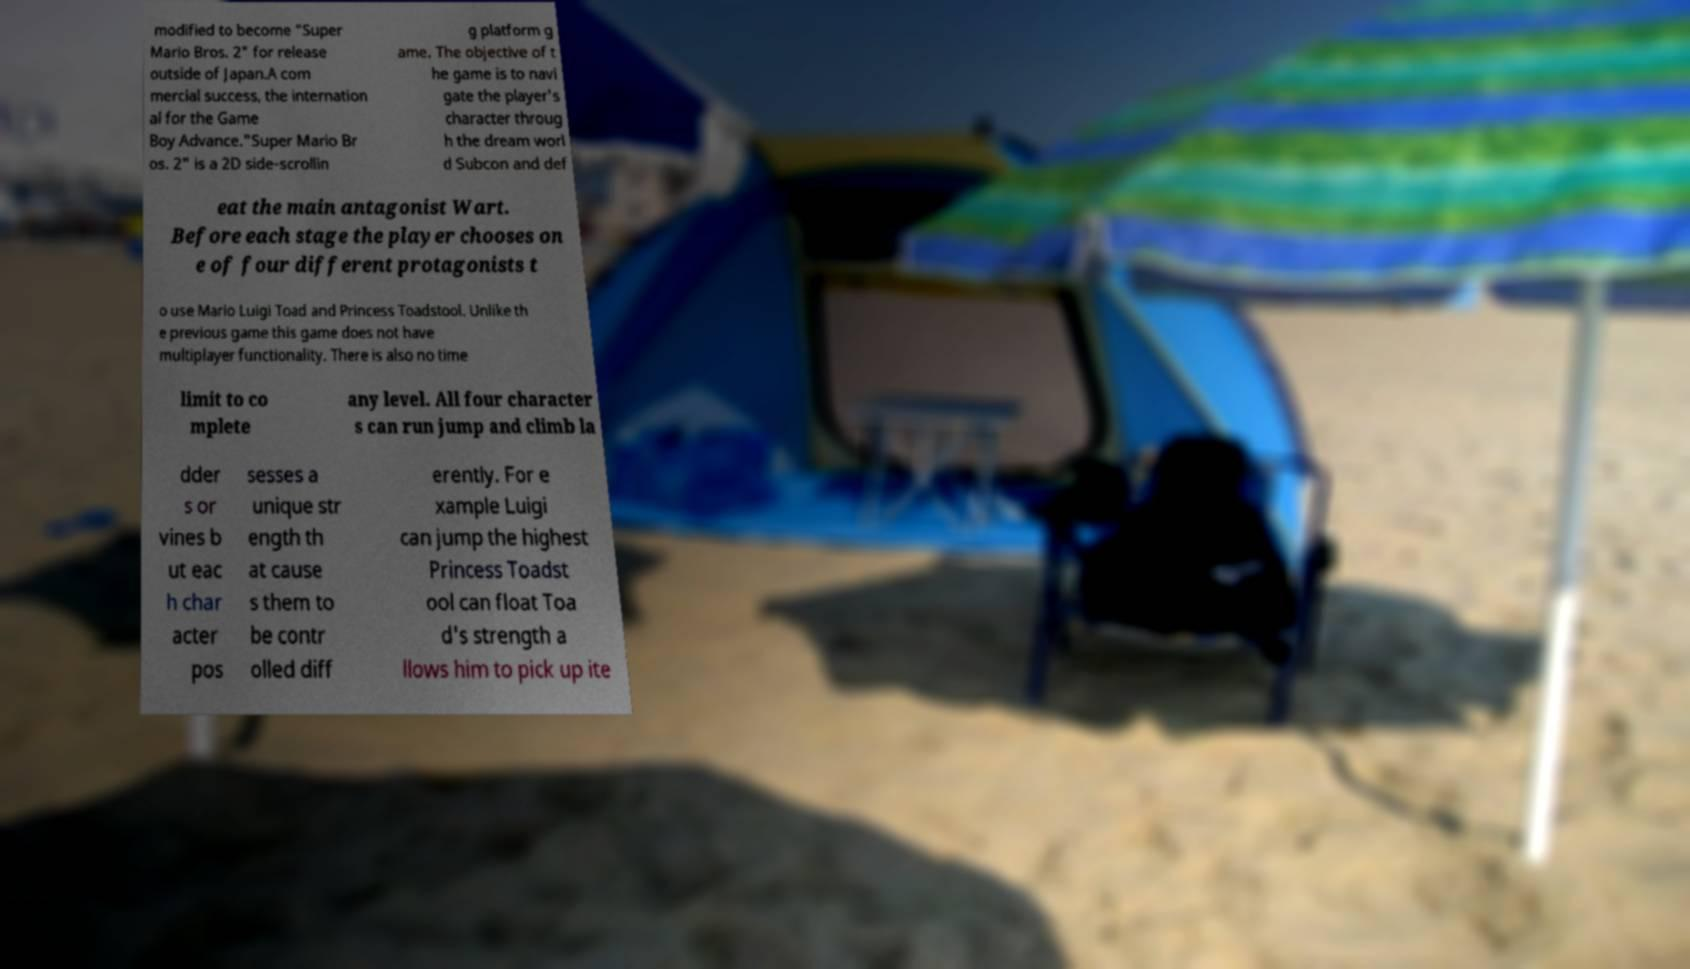There's text embedded in this image that I need extracted. Can you transcribe it verbatim? modified to become "Super Mario Bros. 2" for release outside of Japan.A com mercial success, the internation al for the Game Boy Advance."Super Mario Br os. 2" is a 2D side-scrollin g platform g ame. The objective of t he game is to navi gate the player's character throug h the dream worl d Subcon and def eat the main antagonist Wart. Before each stage the player chooses on e of four different protagonists t o use Mario Luigi Toad and Princess Toadstool. Unlike th e previous game this game does not have multiplayer functionality. There is also no time limit to co mplete any level. All four character s can run jump and climb la dder s or vines b ut eac h char acter pos sesses a unique str ength th at cause s them to be contr olled diff erently. For e xample Luigi can jump the highest Princess Toadst ool can float Toa d's strength a llows him to pick up ite 